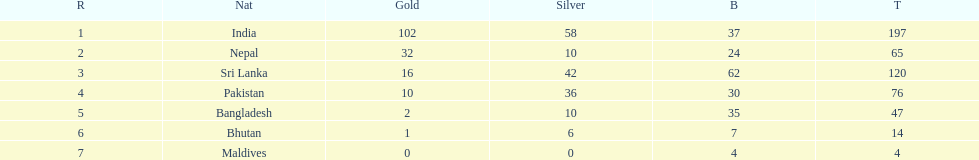What is the difference in total number of medals between india and nepal? 132. Can you parse all the data within this table? {'header': ['R', 'Nat', 'Gold', 'Silver', 'B', 'T'], 'rows': [['1', 'India', '102', '58', '37', '197'], ['2', 'Nepal', '32', '10', '24', '65'], ['3', 'Sri Lanka', '16', '42', '62', '120'], ['4', 'Pakistan', '10', '36', '30', '76'], ['5', 'Bangladesh', '2', '10', '35', '47'], ['6', 'Bhutan', '1', '6', '7', '14'], ['7', 'Maldives', '0', '0', '4', '4']]} 